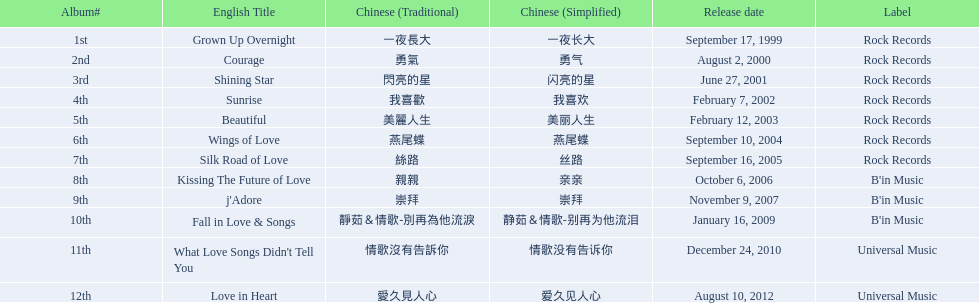Which english titles came out during even years? Courage, Sunrise, Silk Road of Love, Kissing The Future of Love, What Love Songs Didn't Tell You, Love in Heart. Out of the following, which one was launched under b's in music? Kissing The Future of Love. 